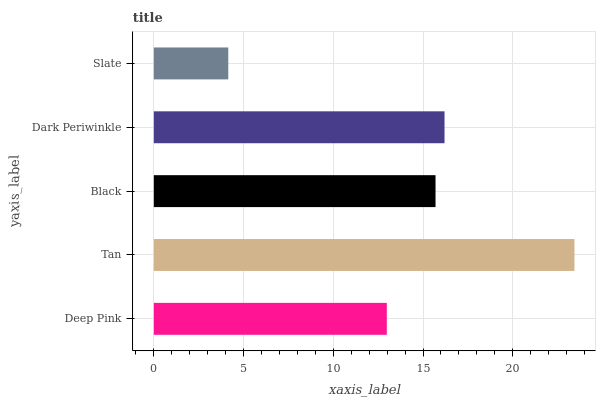Is Slate the minimum?
Answer yes or no. Yes. Is Tan the maximum?
Answer yes or no. Yes. Is Black the minimum?
Answer yes or no. No. Is Black the maximum?
Answer yes or no. No. Is Tan greater than Black?
Answer yes or no. Yes. Is Black less than Tan?
Answer yes or no. Yes. Is Black greater than Tan?
Answer yes or no. No. Is Tan less than Black?
Answer yes or no. No. Is Black the high median?
Answer yes or no. Yes. Is Black the low median?
Answer yes or no. Yes. Is Slate the high median?
Answer yes or no. No. Is Slate the low median?
Answer yes or no. No. 